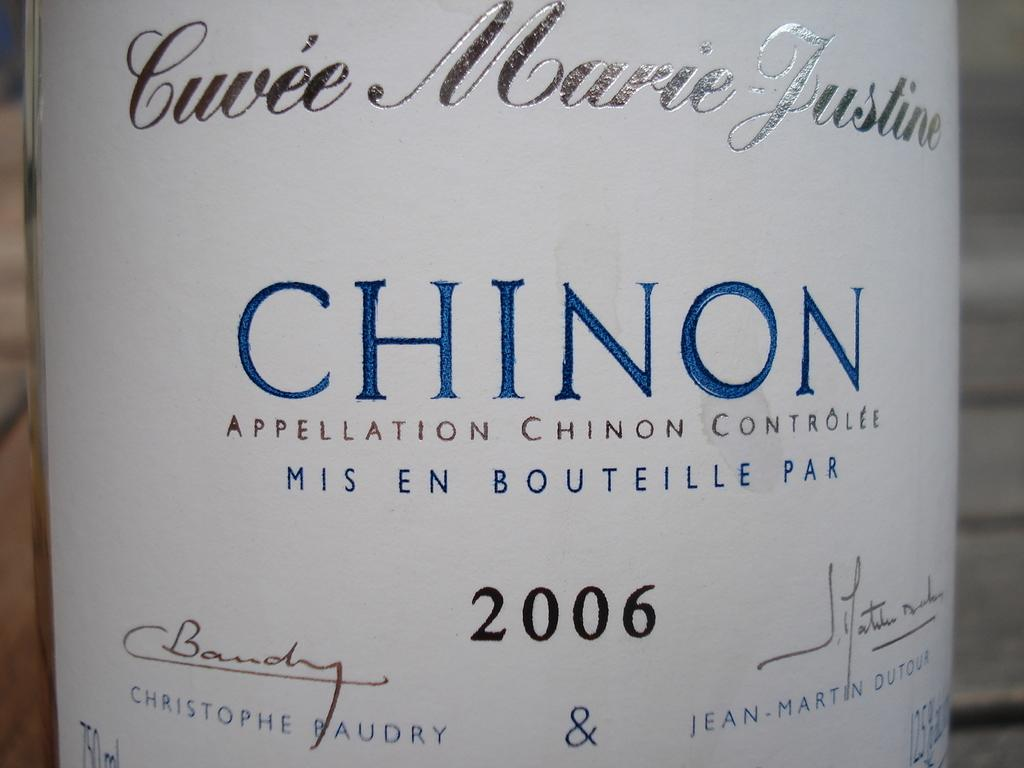<image>
Share a concise interpretation of the image provided. A white label with blue text reads "Chinon." 